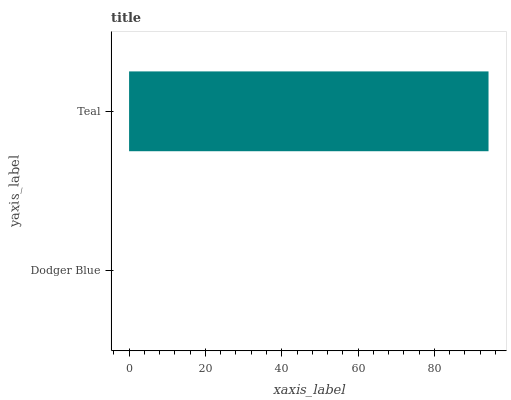Is Dodger Blue the minimum?
Answer yes or no. Yes. Is Teal the maximum?
Answer yes or no. Yes. Is Teal the minimum?
Answer yes or no. No. Is Teal greater than Dodger Blue?
Answer yes or no. Yes. Is Dodger Blue less than Teal?
Answer yes or no. Yes. Is Dodger Blue greater than Teal?
Answer yes or no. No. Is Teal less than Dodger Blue?
Answer yes or no. No. Is Teal the high median?
Answer yes or no. Yes. Is Dodger Blue the low median?
Answer yes or no. Yes. Is Dodger Blue the high median?
Answer yes or no. No. Is Teal the low median?
Answer yes or no. No. 